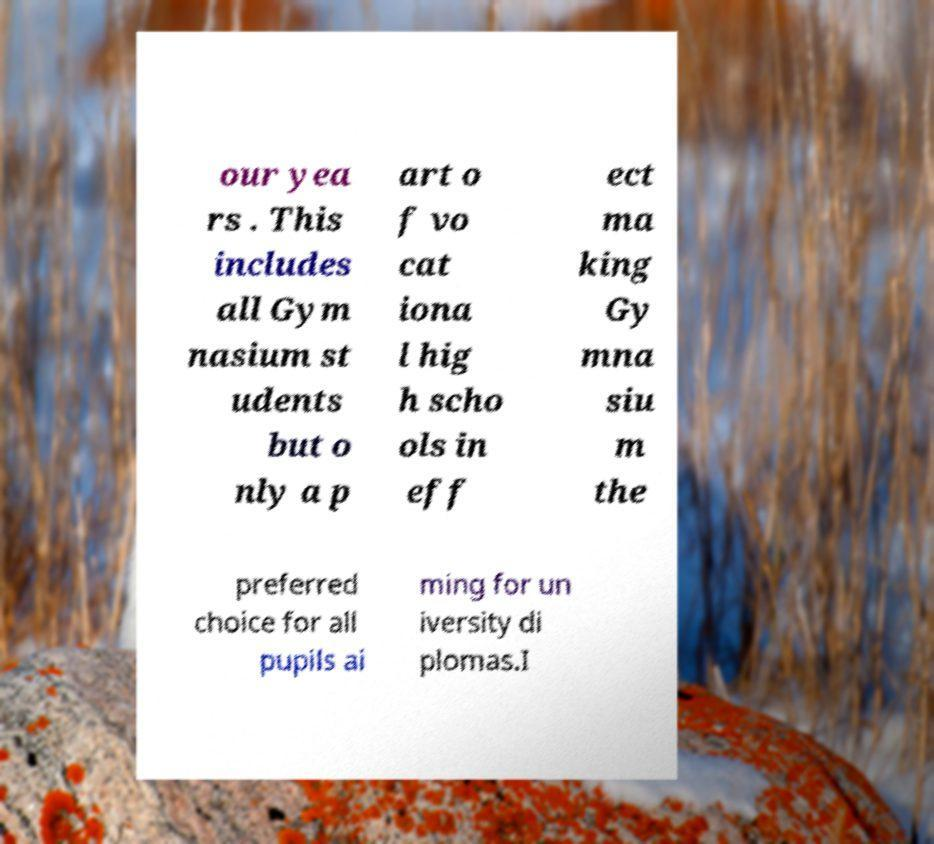What messages or text are displayed in this image? I need them in a readable, typed format. our yea rs . This includes all Gym nasium st udents but o nly a p art o f vo cat iona l hig h scho ols in eff ect ma king Gy mna siu m the preferred choice for all pupils ai ming for un iversity di plomas.I 